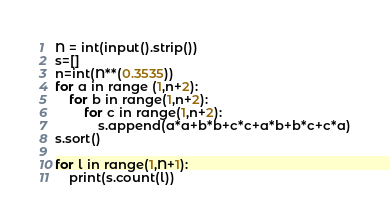<code> <loc_0><loc_0><loc_500><loc_500><_Python_>N = int(input().strip())
s=[]
n=int(N**(0.3535))
for a in range (1,n+2):
    for b in range(1,n+2):
        for c in range(1,n+2):
            s.append(a*a+b*b+c*c+a*b+b*c+c*a)
s.sort()

for l in range(1,N+1):
    print(s.count(l))</code> 